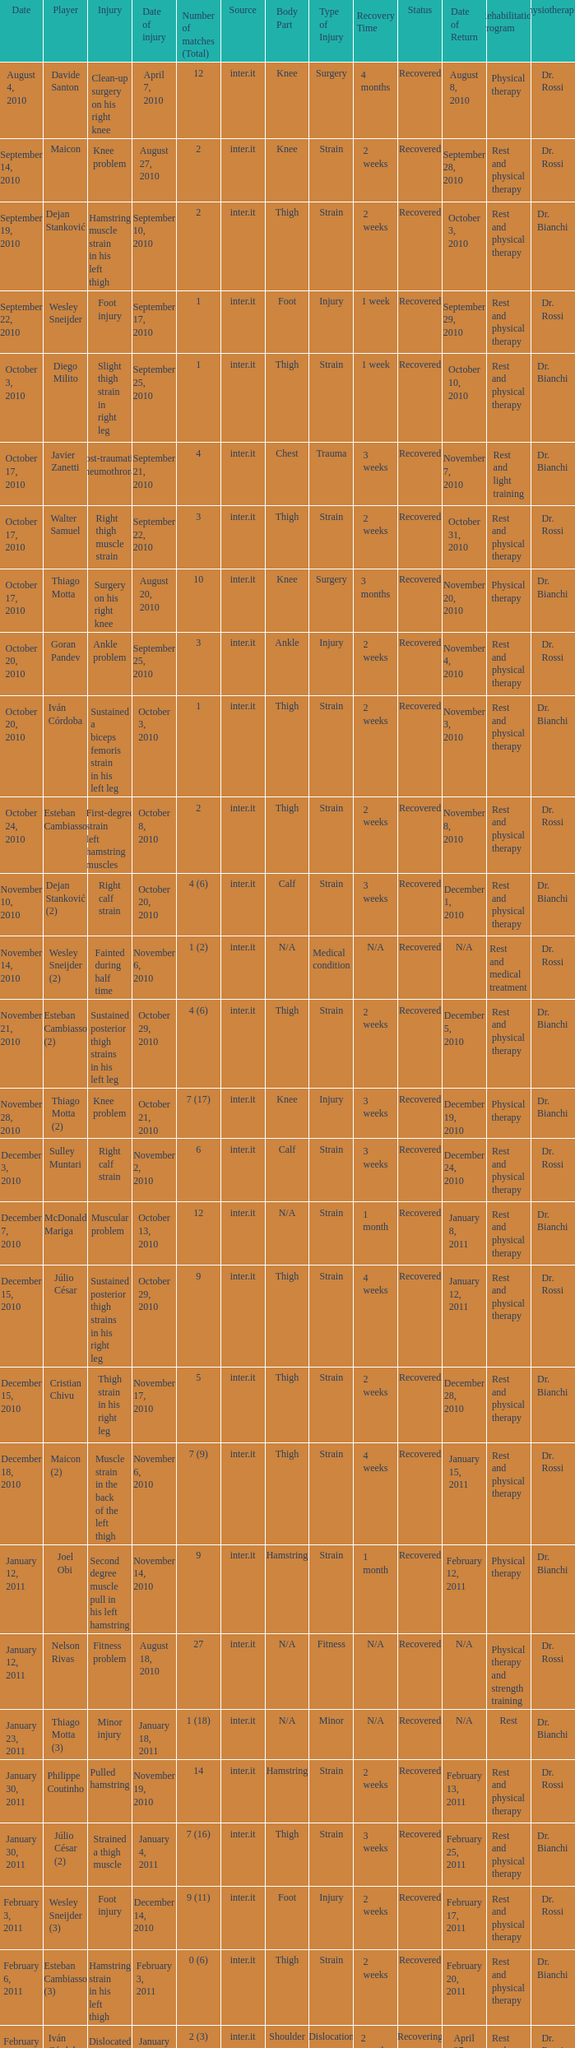What is the date of injury when the injury is sustained posterior thigh strains in his left leg? October 29, 2010. 